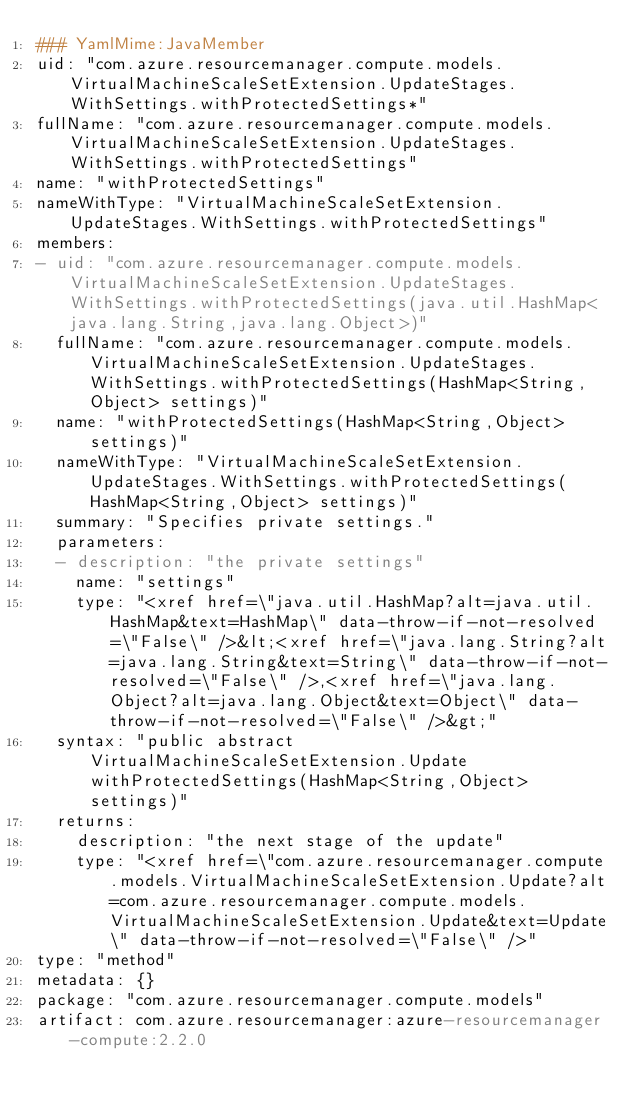<code> <loc_0><loc_0><loc_500><loc_500><_YAML_>### YamlMime:JavaMember
uid: "com.azure.resourcemanager.compute.models.VirtualMachineScaleSetExtension.UpdateStages.WithSettings.withProtectedSettings*"
fullName: "com.azure.resourcemanager.compute.models.VirtualMachineScaleSetExtension.UpdateStages.WithSettings.withProtectedSettings"
name: "withProtectedSettings"
nameWithType: "VirtualMachineScaleSetExtension.UpdateStages.WithSettings.withProtectedSettings"
members:
- uid: "com.azure.resourcemanager.compute.models.VirtualMachineScaleSetExtension.UpdateStages.WithSettings.withProtectedSettings(java.util.HashMap<java.lang.String,java.lang.Object>)"
  fullName: "com.azure.resourcemanager.compute.models.VirtualMachineScaleSetExtension.UpdateStages.WithSettings.withProtectedSettings(HashMap<String,Object> settings)"
  name: "withProtectedSettings(HashMap<String,Object> settings)"
  nameWithType: "VirtualMachineScaleSetExtension.UpdateStages.WithSettings.withProtectedSettings(HashMap<String,Object> settings)"
  summary: "Specifies private settings."
  parameters:
  - description: "the private settings"
    name: "settings"
    type: "<xref href=\"java.util.HashMap?alt=java.util.HashMap&text=HashMap\" data-throw-if-not-resolved=\"False\" />&lt;<xref href=\"java.lang.String?alt=java.lang.String&text=String\" data-throw-if-not-resolved=\"False\" />,<xref href=\"java.lang.Object?alt=java.lang.Object&text=Object\" data-throw-if-not-resolved=\"False\" />&gt;"
  syntax: "public abstract VirtualMachineScaleSetExtension.Update withProtectedSettings(HashMap<String,Object> settings)"
  returns:
    description: "the next stage of the update"
    type: "<xref href=\"com.azure.resourcemanager.compute.models.VirtualMachineScaleSetExtension.Update?alt=com.azure.resourcemanager.compute.models.VirtualMachineScaleSetExtension.Update&text=Update\" data-throw-if-not-resolved=\"False\" />"
type: "method"
metadata: {}
package: "com.azure.resourcemanager.compute.models"
artifact: com.azure.resourcemanager:azure-resourcemanager-compute:2.2.0
</code> 